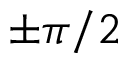Convert formula to latex. <formula><loc_0><loc_0><loc_500><loc_500>\pm \pi / 2</formula> 